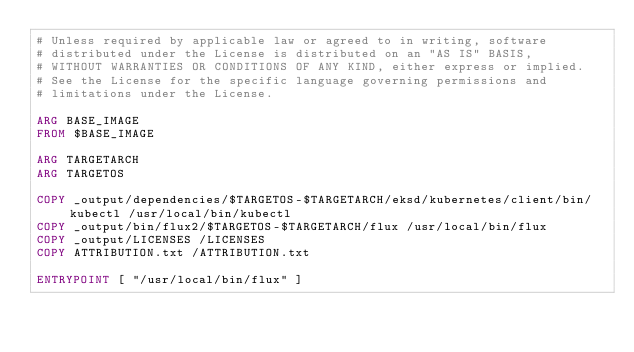Convert code to text. <code><loc_0><loc_0><loc_500><loc_500><_Dockerfile_># Unless required by applicable law or agreed to in writing, software
# distributed under the License is distributed on an "AS IS" BASIS,
# WITHOUT WARRANTIES OR CONDITIONS OF ANY KIND, either express or implied.
# See the License for the specific language governing permissions and
# limitations under the License.

ARG BASE_IMAGE
FROM $BASE_IMAGE

ARG TARGETARCH
ARG TARGETOS

COPY _output/dependencies/$TARGETOS-$TARGETARCH/eksd/kubernetes/client/bin/kubectl /usr/local/bin/kubectl
COPY _output/bin/flux2/$TARGETOS-$TARGETARCH/flux /usr/local/bin/flux
COPY _output/LICENSES /LICENSES
COPY ATTRIBUTION.txt /ATTRIBUTION.txt

ENTRYPOINT [ "/usr/local/bin/flux" ]
</code> 